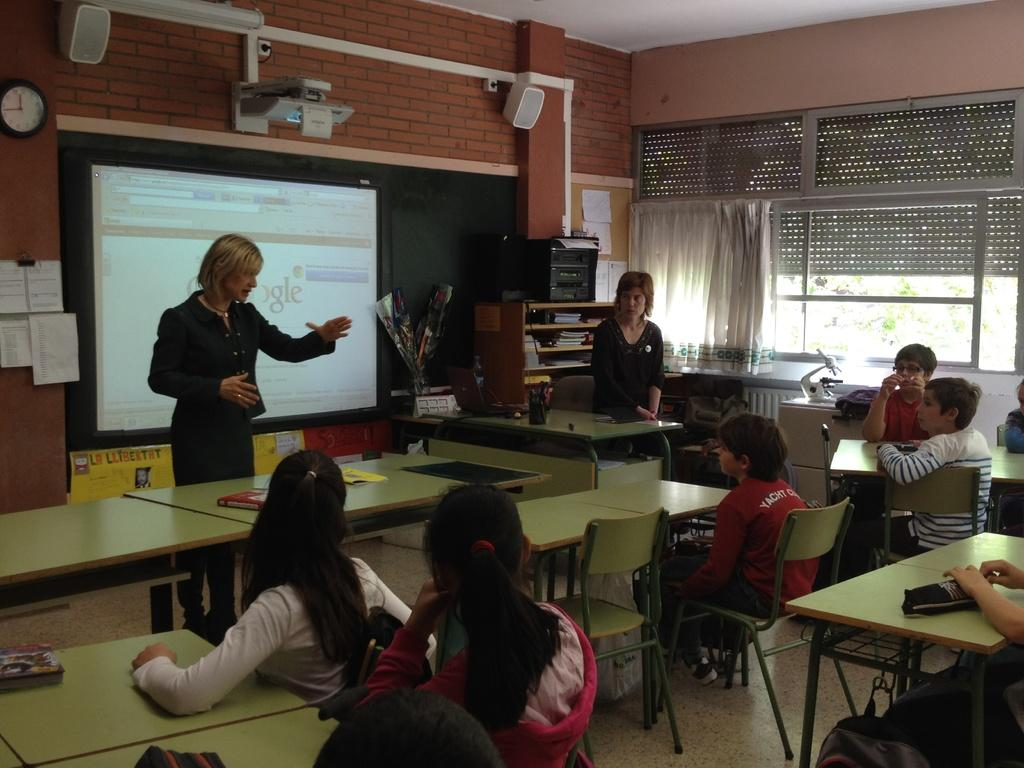Who is the main subject in the image? There is a woman in the image. What is the woman doing in the image? The woman is standing in front of a screen and talking. What can be observed about the kids in the image? There are many kids in the image, and they are sitting on desks. What are the kids doing in the image? The kids are looking at the woman. What is the setting of the image? The setting resembles a classroom. How far away are the planes from the classroom in the image? There are no planes visible in the image, so it is not possible to determine their distance from the classroom. 